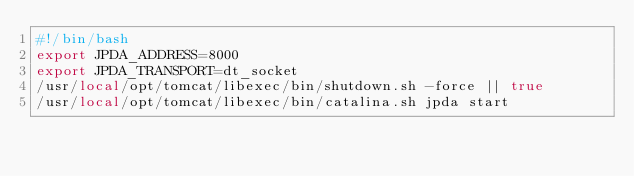Convert code to text. <code><loc_0><loc_0><loc_500><loc_500><_Bash_>#!/bin/bash
export JPDA_ADDRESS=8000
export JPDA_TRANSPORT=dt_socket
/usr/local/opt/tomcat/libexec/bin/shutdown.sh -force || true 
/usr/local/opt/tomcat/libexec/bin/catalina.sh jpda start

</code> 